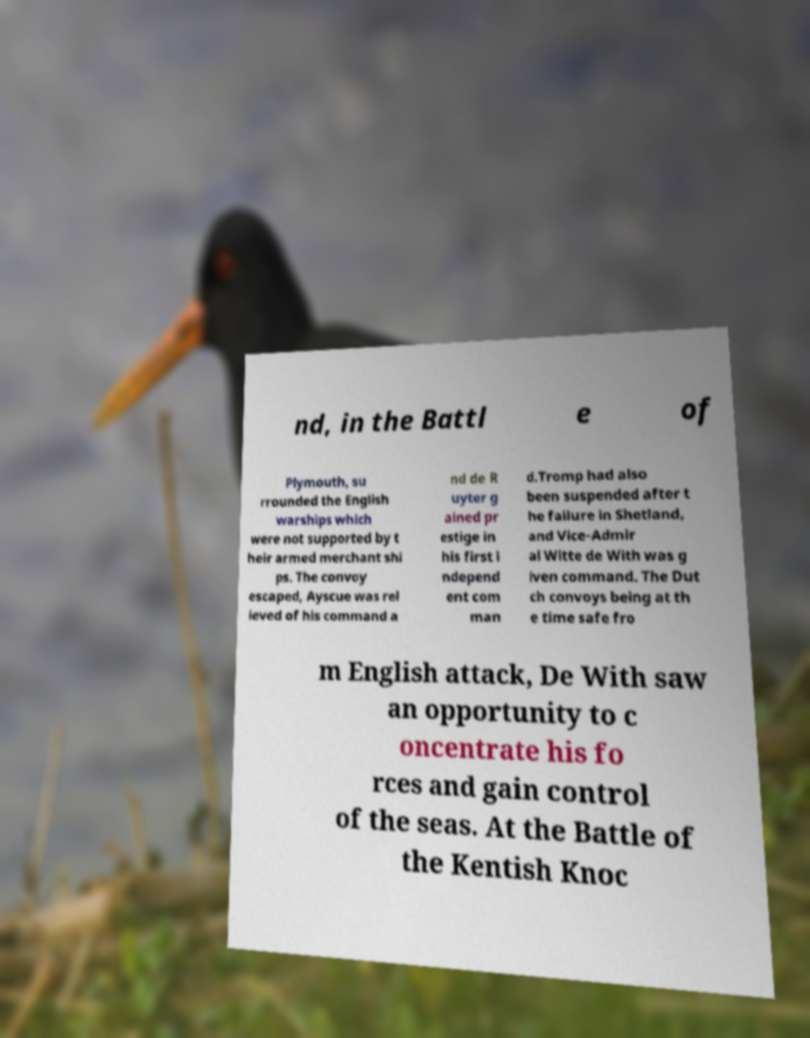Can you accurately transcribe the text from the provided image for me? nd, in the Battl e of Plymouth, su rrounded the English warships which were not supported by t heir armed merchant shi ps. The convoy escaped, Ayscue was rel ieved of his command a nd de R uyter g ained pr estige in his first i ndepend ent com man d.Tromp had also been suspended after t he failure in Shetland, and Vice-Admir al Witte de With was g iven command. The Dut ch convoys being at th e time safe fro m English attack, De With saw an opportunity to c oncentrate his fo rces and gain control of the seas. At the Battle of the Kentish Knoc 